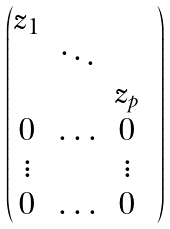<formula> <loc_0><loc_0><loc_500><loc_500>\begin{pmatrix} z _ { 1 } & & & \\ & \ddots & & \\ & & z _ { p } & \\ 0 & \hdots & 0 & \\ \vdots & & \vdots & \\ 0 & \hdots & 0 & \end{pmatrix}</formula> 